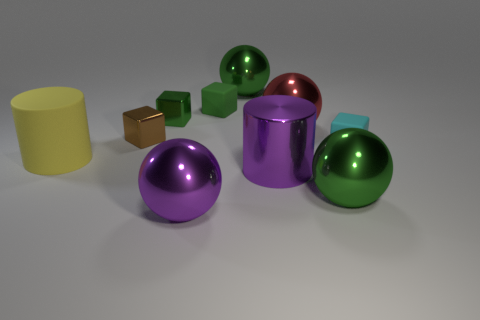Subtract all cyan matte cubes. How many cubes are left? 3 Subtract all purple cylinders. How many cylinders are left? 1 Subtract all balls. How many objects are left? 6 Subtract all gray cylinders. How many yellow balls are left? 0 Subtract 0 brown balls. How many objects are left? 10 Subtract 1 cylinders. How many cylinders are left? 1 Subtract all yellow balls. Subtract all red cubes. How many balls are left? 4 Subtract all metal things. Subtract all large red shiny cylinders. How many objects are left? 3 Add 9 large yellow things. How many large yellow things are left? 10 Add 6 green cubes. How many green cubes exist? 8 